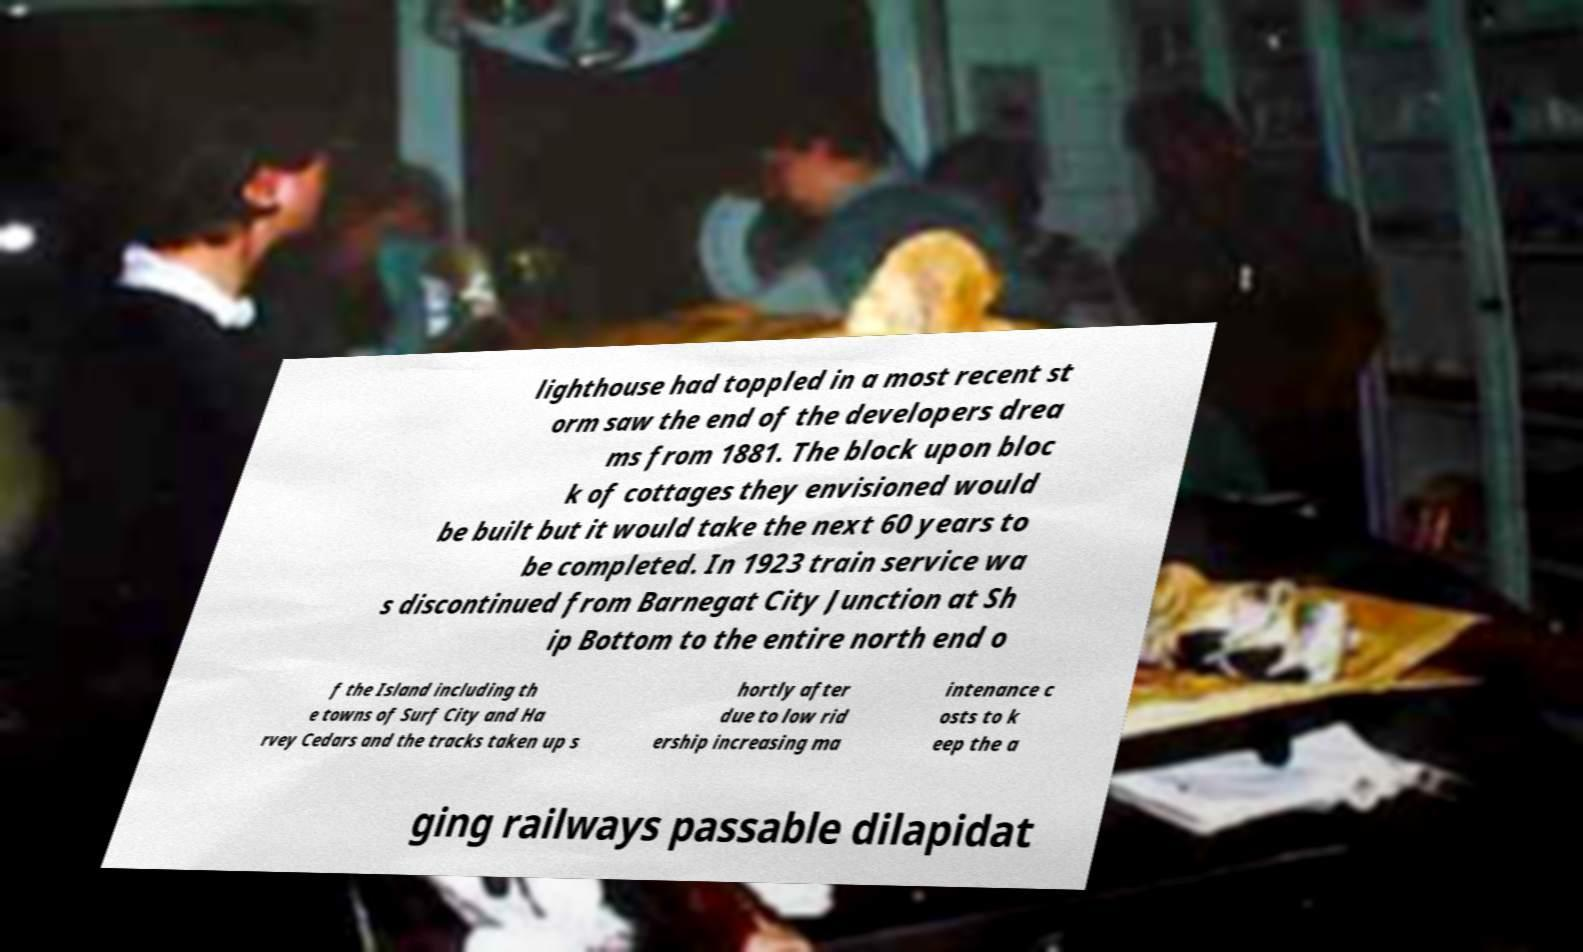Please identify and transcribe the text found in this image. lighthouse had toppled in a most recent st orm saw the end of the developers drea ms from 1881. The block upon bloc k of cottages they envisioned would be built but it would take the next 60 years to be completed. In 1923 train service wa s discontinued from Barnegat City Junction at Sh ip Bottom to the entire north end o f the Island including th e towns of Surf City and Ha rvey Cedars and the tracks taken up s hortly after due to low rid ership increasing ma intenance c osts to k eep the a ging railways passable dilapidat 